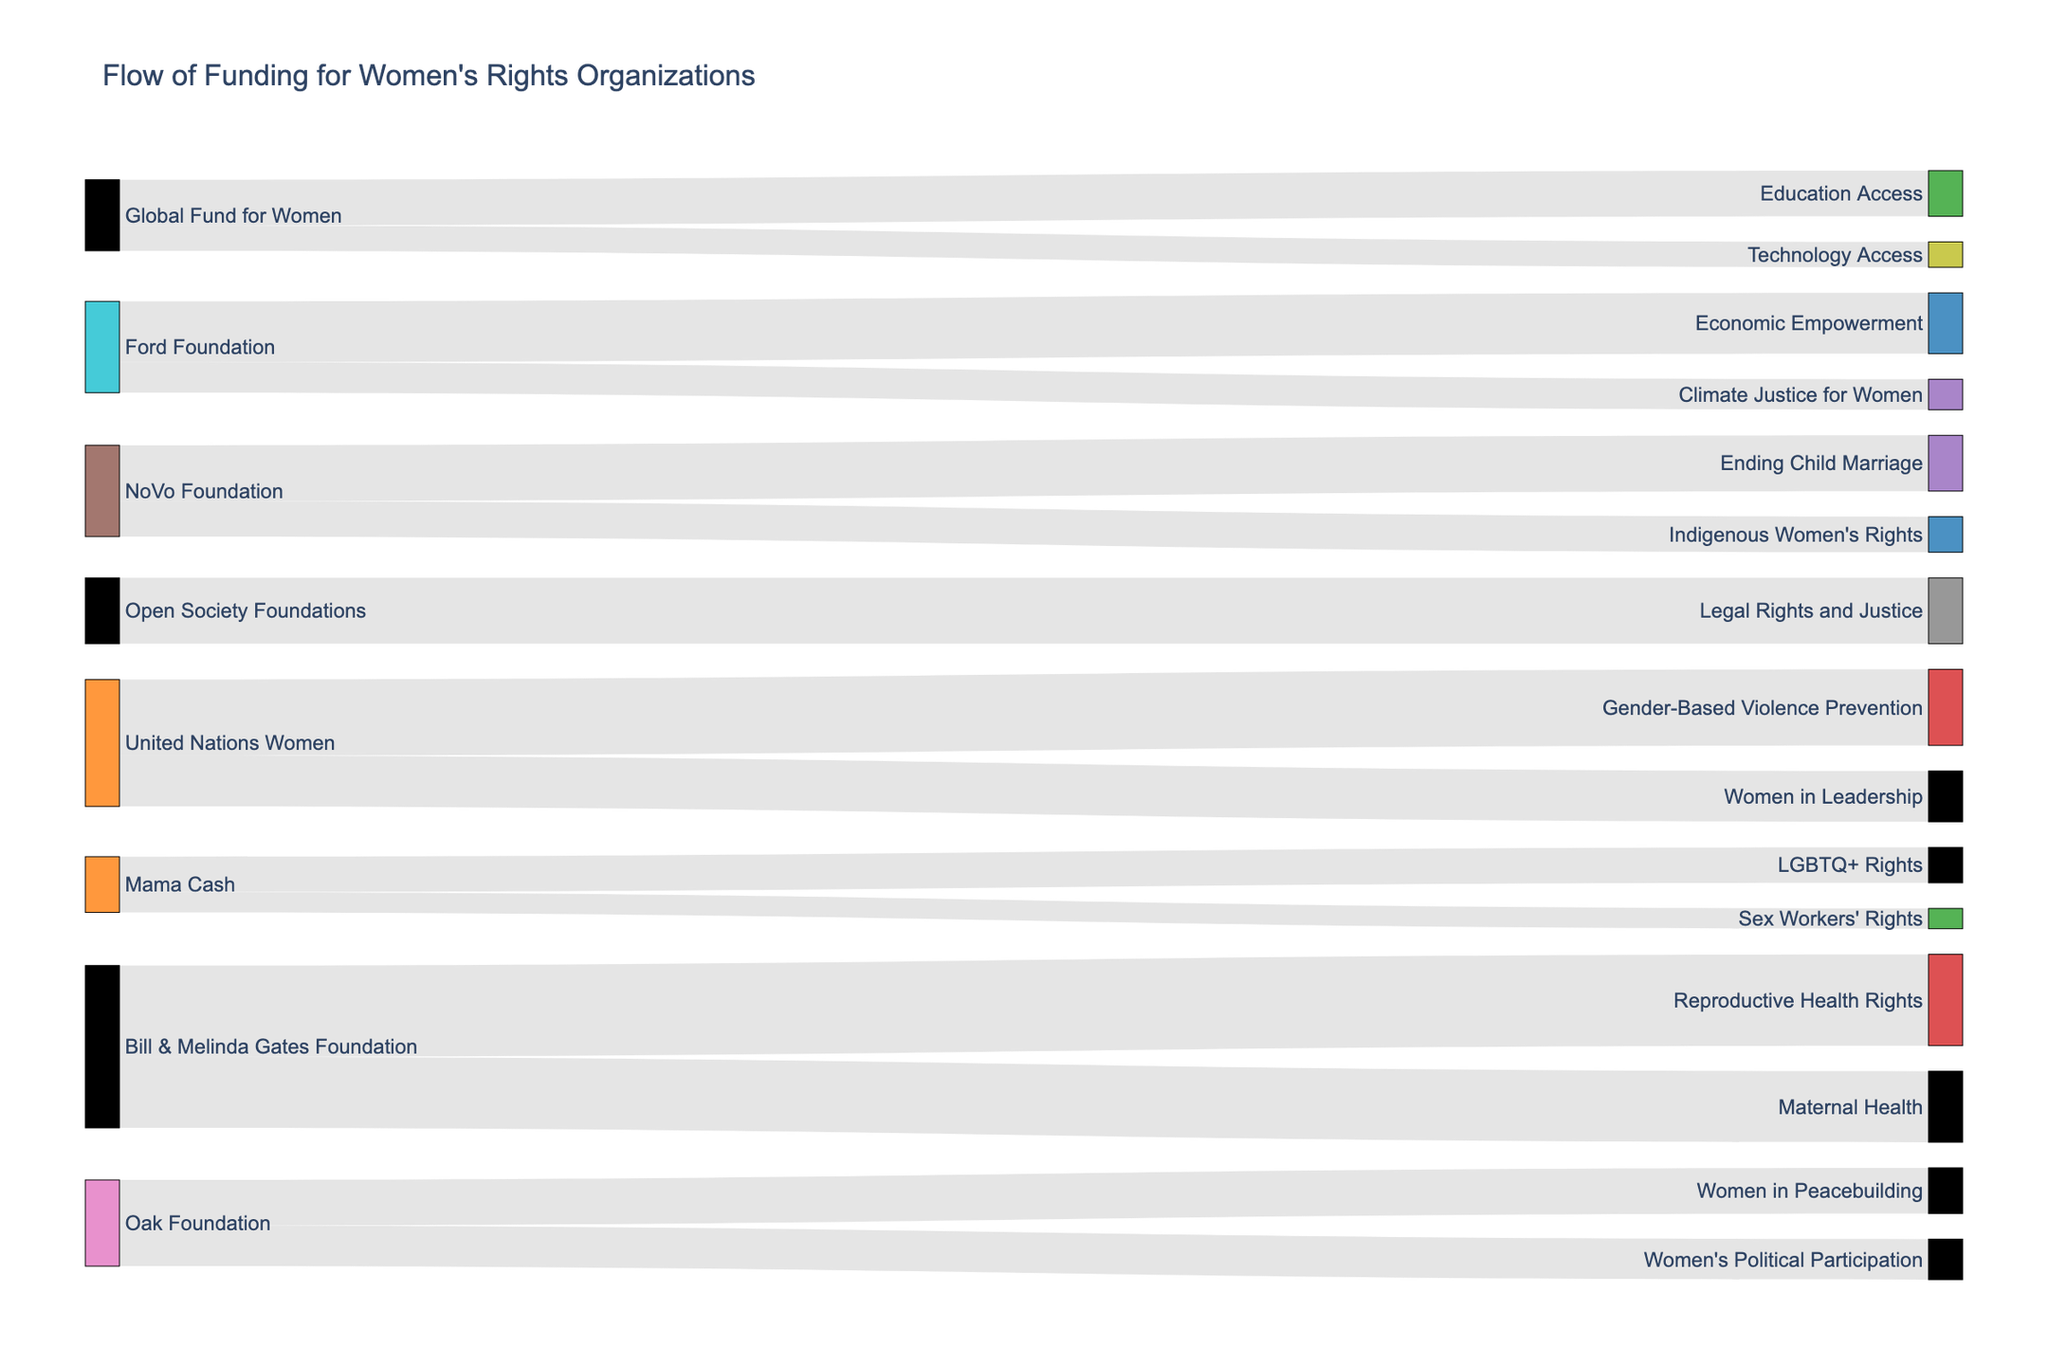What is the total amount of funding provided by the Bill & Melinda Gates Foundation? Add up the values of all causes funded by the Bill & Melinda Gates Foundation: Reproductive Health Rights ($18,000,000) + Maternal Health ($14,000,000). The total is $18,000,000 + $14,000,000 = $32,000,000
Answer: $32,000,000 Which cause received the least funding? Identify the cause with the smallest value from the data table: Technology Access received $5,000,000
Answer: Technology Access How much more funding did Economic Empowerment receive compared to Technology Access? Find the funding values for both causes: Economic Empowerment ($12,000,000) and Technology Access ($5,000,000). Calculate the difference: $12,000,000 - $5,000,000 = $7,000,000
Answer: $7,000,000 Which organization provided the largest single contribution and to which cause was it allocated? Locate the highest funding value in the data table. The largest single contribution is from the Bill & Melinda Gates Foundation to Reproductive Health Rights with $18,000,000
Answer: Bill & Melinda Gates Foundation to Reproductive Health Rights How many unique funding sources are there? Count the distinct sources listed in the data table: United Nations Women, Ford Foundation, Bill & Melinda Gates Foundation, Global Fund for Women, Mama Cash, NoVo Foundation, Oak Foundation, Open Society Foundations. There are 8 unique funding sources
Answer: 8 What is the combined funding for Indigenous Women's Rights and LGBTQ+ Rights? Add the values for both causes: Indigenous Women's Rights ($7,000,000) + LGBTQ+ Rights ($7,000,000). The total is $7,000,000 + $7,000,000 = $14,000,000
Answer: $14,000,000 How many causes received funding from the United Nations Women? Count the number of unique causes funded by the United Nations Women in the data table: Gender-Based Violence Prevention, and Women in Leadership. There are 2 causes
Answer: 2 Which organization funded the most diverse set of causes? Determine which funding source has the highest number of distinct target causes in the data table. The foundation with the most diverse set of causes is Bill & Melinda Gates Foundation, which funded Reproductive Health Rights and Maternal Health
Answer: Bill & Melinda Gates Foundation 